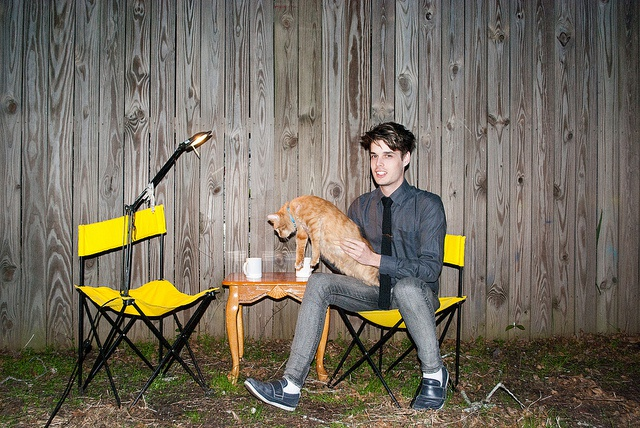Describe the objects in this image and their specific colors. I can see people in black, gray, darkgray, and blue tones, chair in black, gold, gray, and darkgray tones, chair in black, darkgreen, gray, and gold tones, cat in black, tan, and lightgray tones, and dining table in black, orange, red, and tan tones in this image. 